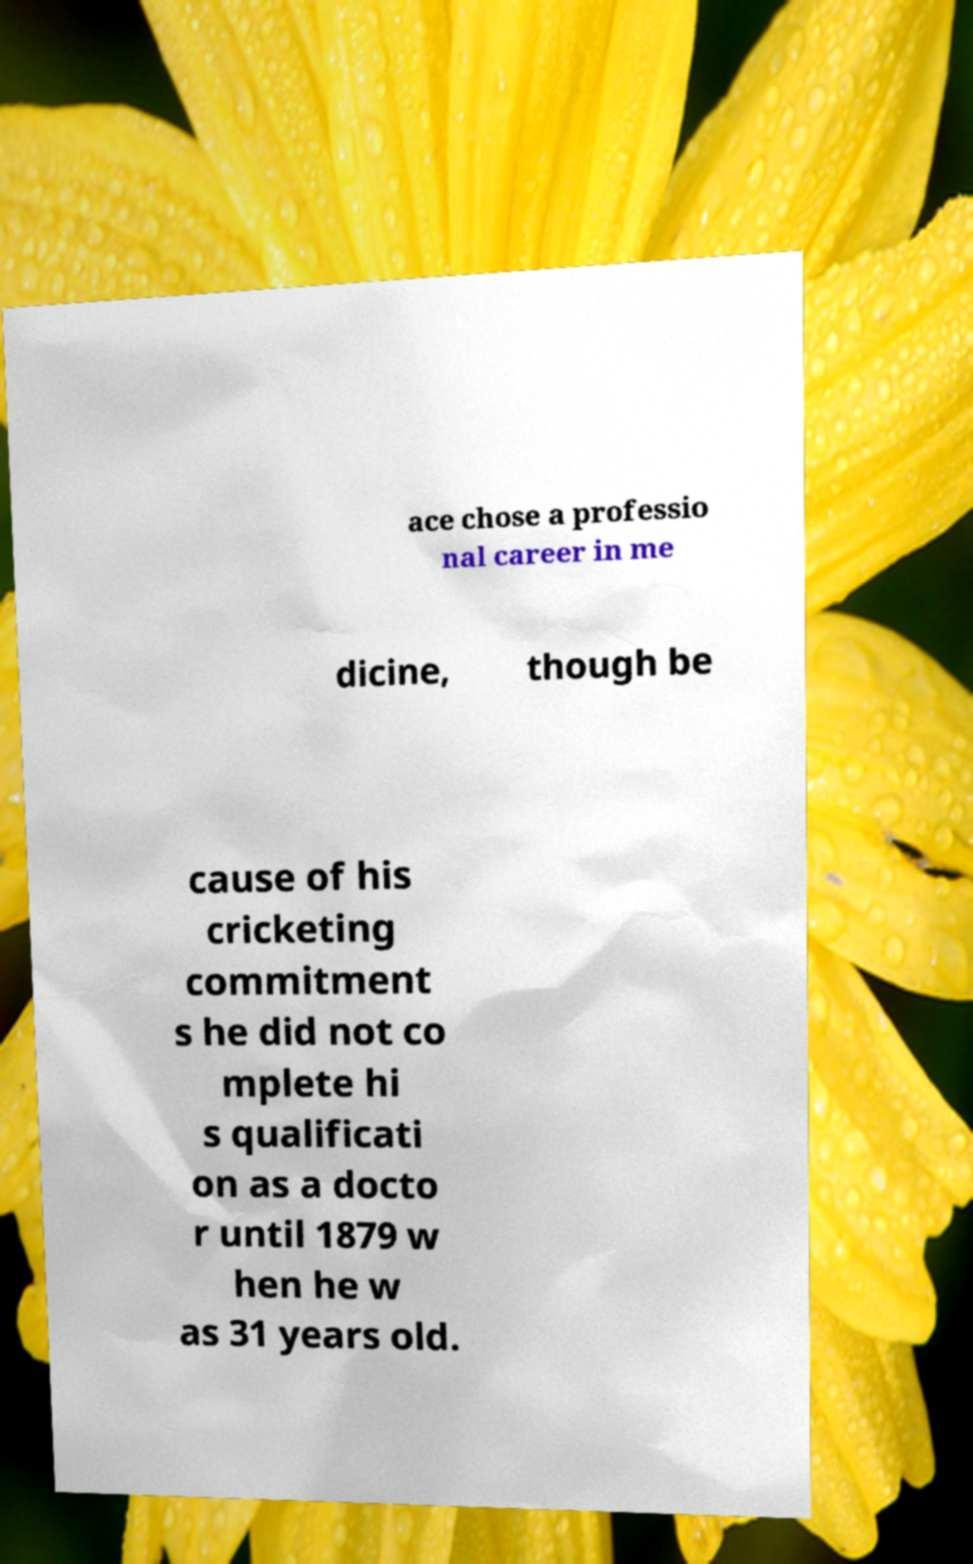I need the written content from this picture converted into text. Can you do that? ace chose a professio nal career in me dicine, though be cause of his cricketing commitment s he did not co mplete hi s qualificati on as a docto r until 1879 w hen he w as 31 years old. 